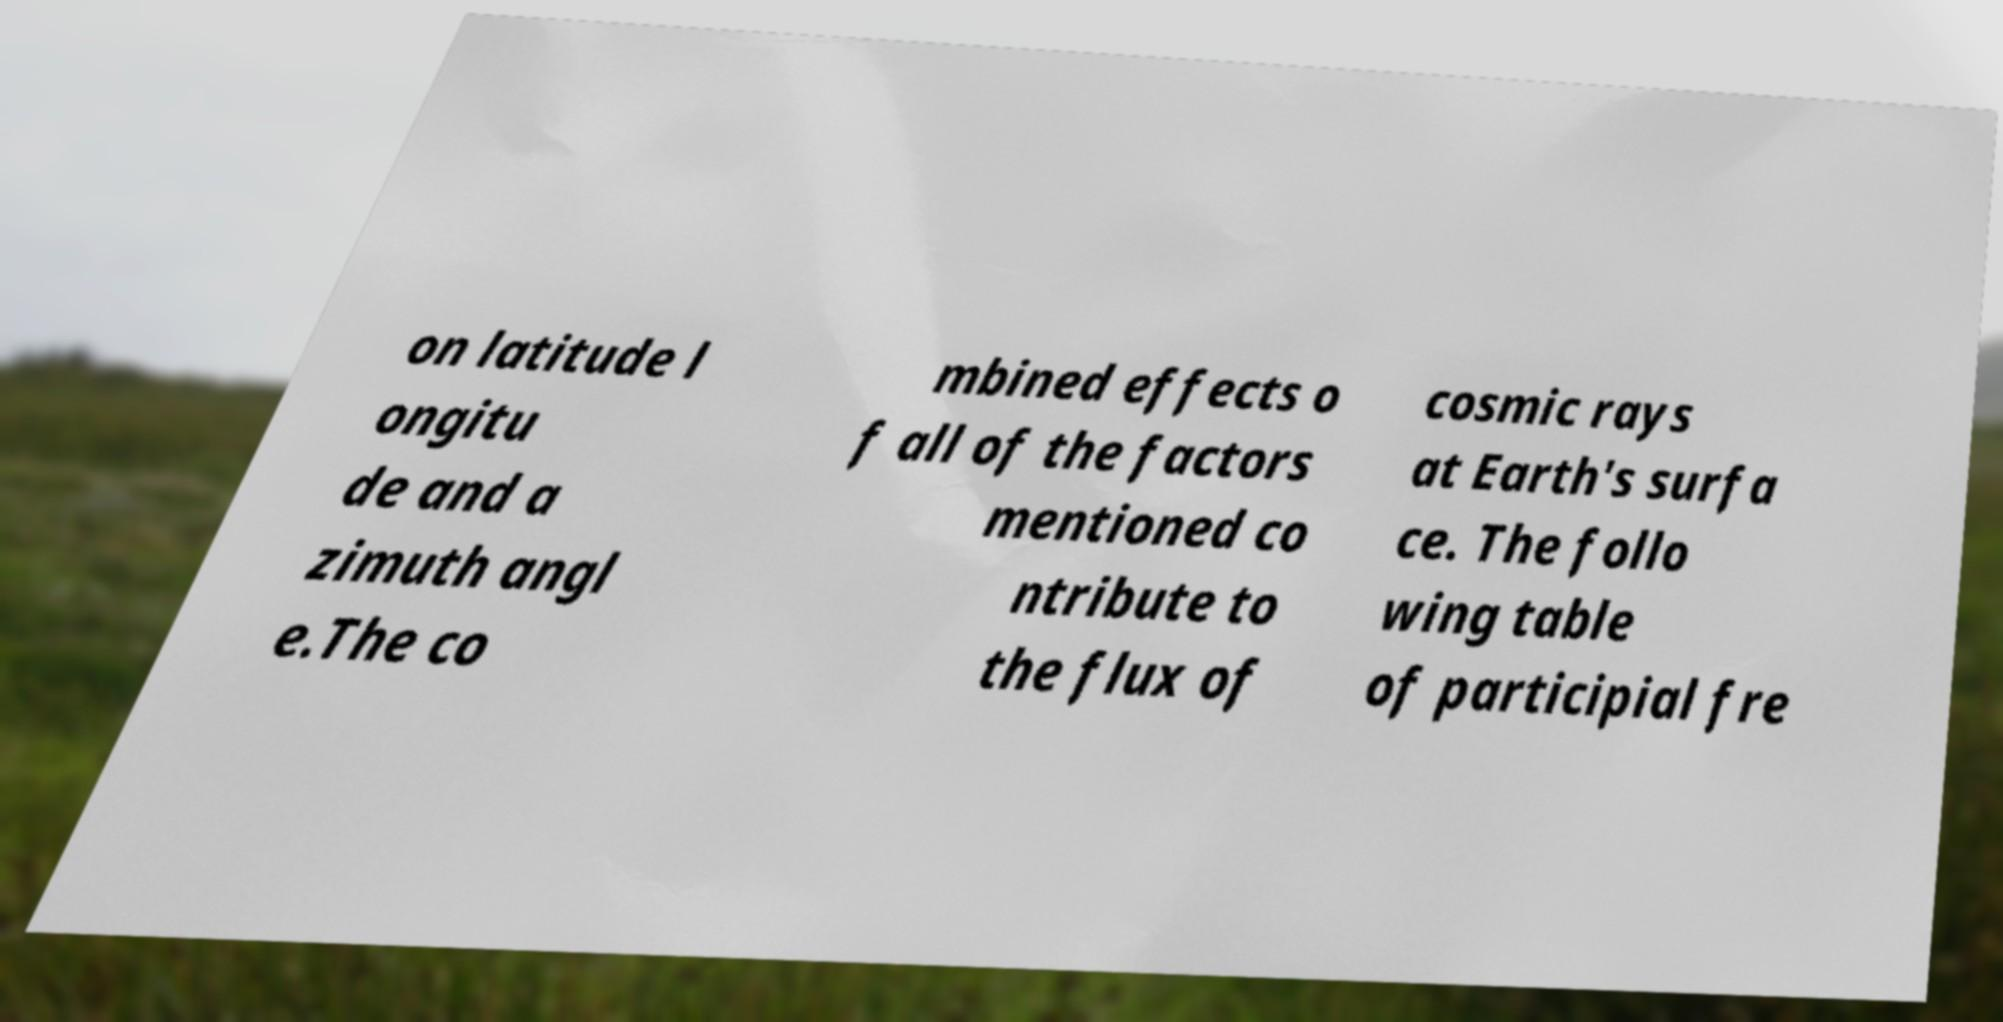Please identify and transcribe the text found in this image. on latitude l ongitu de and a zimuth angl e.The co mbined effects o f all of the factors mentioned co ntribute to the flux of cosmic rays at Earth's surfa ce. The follo wing table of participial fre 